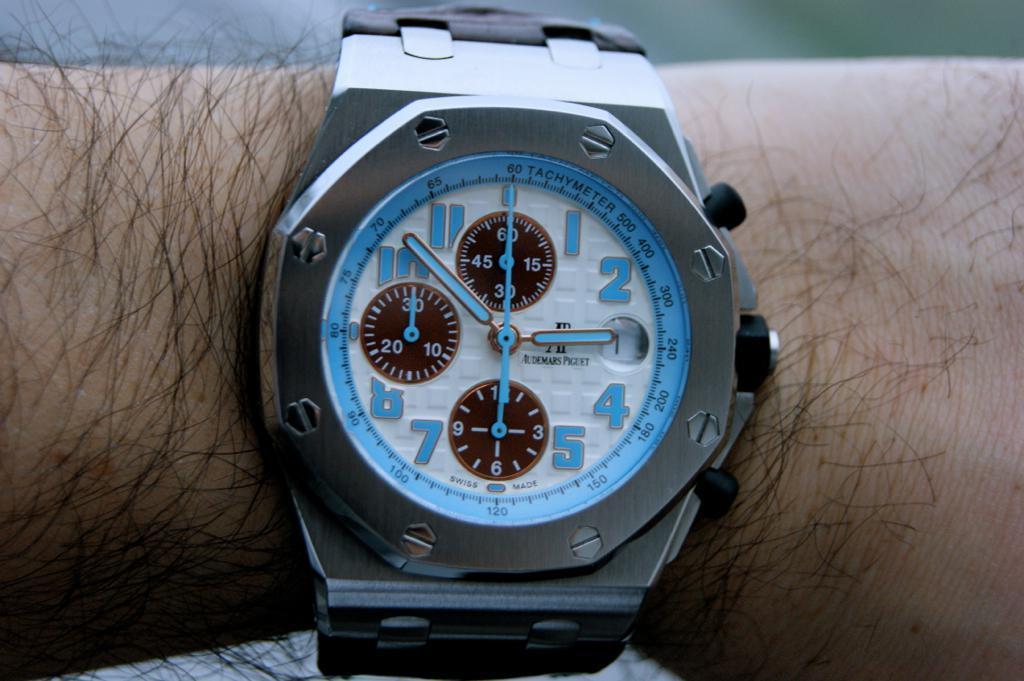Describe this image in one or two sentences. In this image I can see a human hand. I can also see a watch to the hand. 